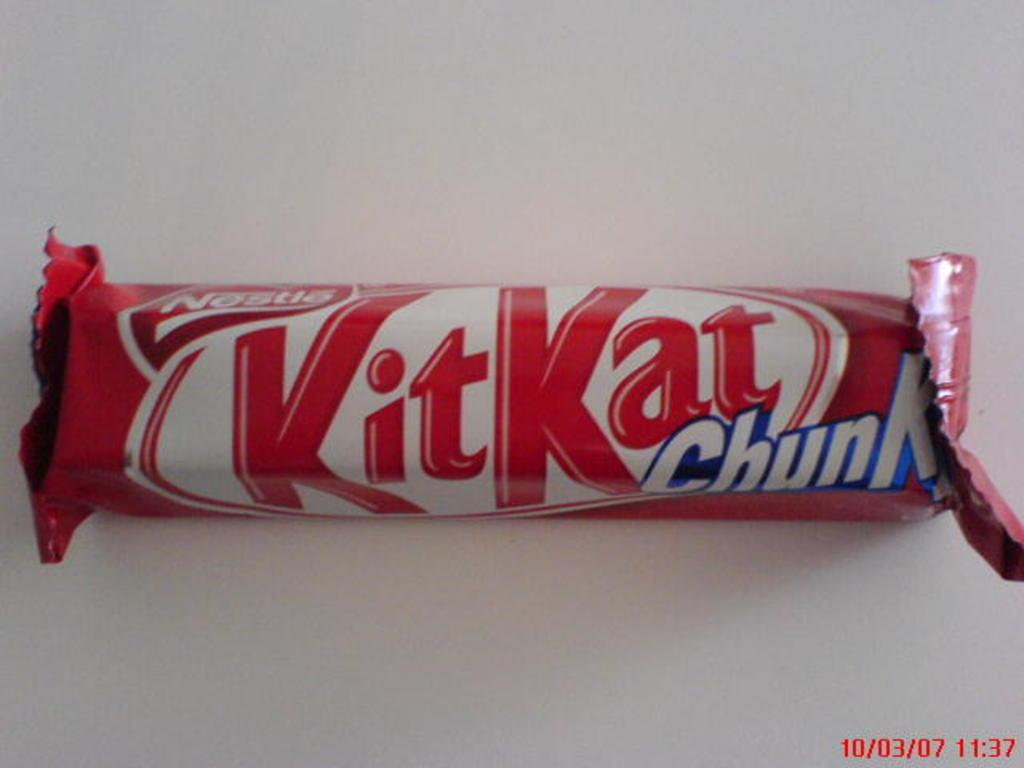What is the main subject of the image? The main subject of the image is a chocolate. Where is the chocolate located in the image? The chocolate is in the middle of the image. What is the color of the surface on which the chocolate is placed? The chocolate is on a white surface. What can be seen on the chocolate wrapper? There is text on the chocolate wrapper. What type of fowl can be seen laying eggs in the image? There is no fowl or eggs present in the image; it features a chocolate on a white surface with text on the wrapper. 